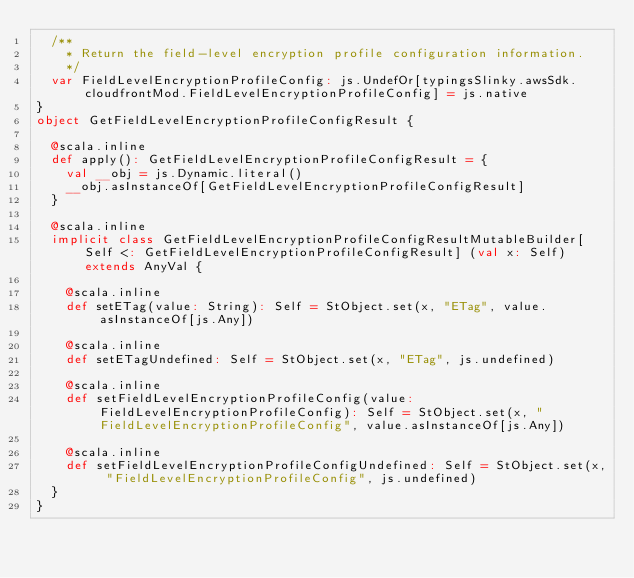<code> <loc_0><loc_0><loc_500><loc_500><_Scala_>  /**
    * Return the field-level encryption profile configuration information.
    */
  var FieldLevelEncryptionProfileConfig: js.UndefOr[typingsSlinky.awsSdk.cloudfrontMod.FieldLevelEncryptionProfileConfig] = js.native
}
object GetFieldLevelEncryptionProfileConfigResult {
  
  @scala.inline
  def apply(): GetFieldLevelEncryptionProfileConfigResult = {
    val __obj = js.Dynamic.literal()
    __obj.asInstanceOf[GetFieldLevelEncryptionProfileConfigResult]
  }
  
  @scala.inline
  implicit class GetFieldLevelEncryptionProfileConfigResultMutableBuilder[Self <: GetFieldLevelEncryptionProfileConfigResult] (val x: Self) extends AnyVal {
    
    @scala.inline
    def setETag(value: String): Self = StObject.set(x, "ETag", value.asInstanceOf[js.Any])
    
    @scala.inline
    def setETagUndefined: Self = StObject.set(x, "ETag", js.undefined)
    
    @scala.inline
    def setFieldLevelEncryptionProfileConfig(value: FieldLevelEncryptionProfileConfig): Self = StObject.set(x, "FieldLevelEncryptionProfileConfig", value.asInstanceOf[js.Any])
    
    @scala.inline
    def setFieldLevelEncryptionProfileConfigUndefined: Self = StObject.set(x, "FieldLevelEncryptionProfileConfig", js.undefined)
  }
}
</code> 